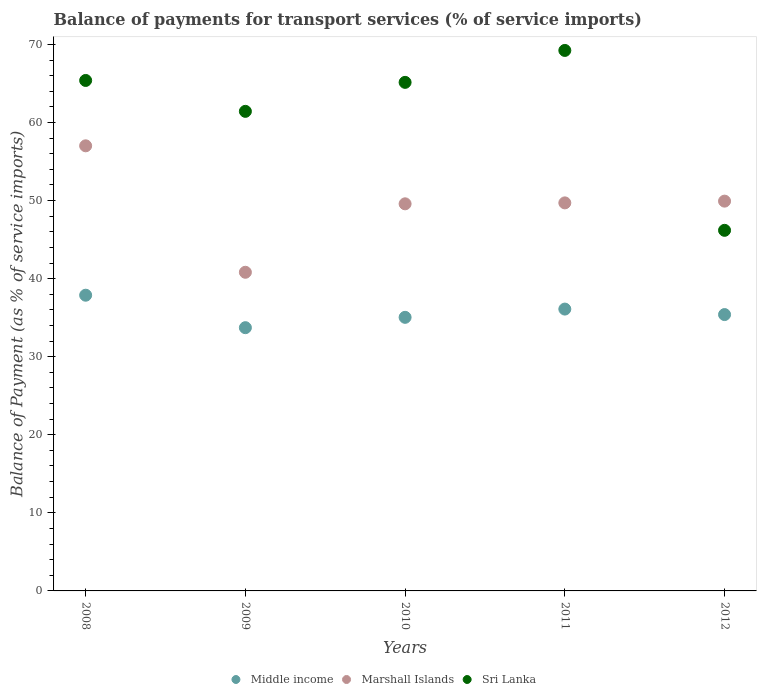How many different coloured dotlines are there?
Make the answer very short. 3. What is the balance of payments for transport services in Marshall Islands in 2009?
Keep it short and to the point. 40.81. Across all years, what is the maximum balance of payments for transport services in Middle income?
Make the answer very short. 37.88. Across all years, what is the minimum balance of payments for transport services in Sri Lanka?
Your answer should be very brief. 46.18. In which year was the balance of payments for transport services in Middle income maximum?
Provide a succinct answer. 2008. In which year was the balance of payments for transport services in Middle income minimum?
Give a very brief answer. 2009. What is the total balance of payments for transport services in Middle income in the graph?
Your response must be concise. 178.12. What is the difference between the balance of payments for transport services in Marshall Islands in 2008 and that in 2009?
Ensure brevity in your answer.  16.2. What is the difference between the balance of payments for transport services in Sri Lanka in 2011 and the balance of payments for transport services in Marshall Islands in 2009?
Ensure brevity in your answer.  28.41. What is the average balance of payments for transport services in Marshall Islands per year?
Keep it short and to the point. 49.41. In the year 2011, what is the difference between the balance of payments for transport services in Marshall Islands and balance of payments for transport services in Middle income?
Provide a succinct answer. 13.6. What is the ratio of the balance of payments for transport services in Marshall Islands in 2008 to that in 2011?
Make the answer very short. 1.15. What is the difference between the highest and the second highest balance of payments for transport services in Sri Lanka?
Give a very brief answer. 3.84. What is the difference between the highest and the lowest balance of payments for transport services in Middle income?
Your answer should be compact. 4.16. In how many years, is the balance of payments for transport services in Sri Lanka greater than the average balance of payments for transport services in Sri Lanka taken over all years?
Offer a terse response. 3. Is it the case that in every year, the sum of the balance of payments for transport services in Sri Lanka and balance of payments for transport services in Marshall Islands  is greater than the balance of payments for transport services in Middle income?
Provide a succinct answer. Yes. Does the balance of payments for transport services in Sri Lanka monotonically increase over the years?
Give a very brief answer. No. Is the balance of payments for transport services in Marshall Islands strictly less than the balance of payments for transport services in Sri Lanka over the years?
Make the answer very short. No. How many dotlines are there?
Give a very brief answer. 3. How many years are there in the graph?
Your answer should be very brief. 5. Does the graph contain any zero values?
Offer a terse response. No. Does the graph contain grids?
Your answer should be compact. No. How many legend labels are there?
Provide a short and direct response. 3. What is the title of the graph?
Provide a short and direct response. Balance of payments for transport services (% of service imports). Does "Belize" appear as one of the legend labels in the graph?
Offer a terse response. No. What is the label or title of the X-axis?
Make the answer very short. Years. What is the label or title of the Y-axis?
Your answer should be very brief. Balance of Payment (as % of service imports). What is the Balance of Payment (as % of service imports) in Middle income in 2008?
Give a very brief answer. 37.88. What is the Balance of Payment (as % of service imports) of Marshall Islands in 2008?
Ensure brevity in your answer.  57.01. What is the Balance of Payment (as % of service imports) in Sri Lanka in 2008?
Make the answer very short. 65.38. What is the Balance of Payment (as % of service imports) in Middle income in 2009?
Offer a terse response. 33.72. What is the Balance of Payment (as % of service imports) of Marshall Islands in 2009?
Your response must be concise. 40.81. What is the Balance of Payment (as % of service imports) of Sri Lanka in 2009?
Keep it short and to the point. 61.42. What is the Balance of Payment (as % of service imports) of Middle income in 2010?
Ensure brevity in your answer.  35.04. What is the Balance of Payment (as % of service imports) of Marshall Islands in 2010?
Keep it short and to the point. 49.58. What is the Balance of Payment (as % of service imports) in Sri Lanka in 2010?
Your answer should be compact. 65.14. What is the Balance of Payment (as % of service imports) of Middle income in 2011?
Provide a short and direct response. 36.1. What is the Balance of Payment (as % of service imports) of Marshall Islands in 2011?
Your answer should be compact. 49.7. What is the Balance of Payment (as % of service imports) of Sri Lanka in 2011?
Ensure brevity in your answer.  69.23. What is the Balance of Payment (as % of service imports) in Middle income in 2012?
Your response must be concise. 35.39. What is the Balance of Payment (as % of service imports) of Marshall Islands in 2012?
Your answer should be very brief. 49.92. What is the Balance of Payment (as % of service imports) of Sri Lanka in 2012?
Your answer should be very brief. 46.18. Across all years, what is the maximum Balance of Payment (as % of service imports) in Middle income?
Keep it short and to the point. 37.88. Across all years, what is the maximum Balance of Payment (as % of service imports) of Marshall Islands?
Ensure brevity in your answer.  57.01. Across all years, what is the maximum Balance of Payment (as % of service imports) in Sri Lanka?
Make the answer very short. 69.23. Across all years, what is the minimum Balance of Payment (as % of service imports) of Middle income?
Make the answer very short. 33.72. Across all years, what is the minimum Balance of Payment (as % of service imports) in Marshall Islands?
Ensure brevity in your answer.  40.81. Across all years, what is the minimum Balance of Payment (as % of service imports) of Sri Lanka?
Provide a short and direct response. 46.18. What is the total Balance of Payment (as % of service imports) of Middle income in the graph?
Provide a succinct answer. 178.12. What is the total Balance of Payment (as % of service imports) in Marshall Islands in the graph?
Give a very brief answer. 247.03. What is the total Balance of Payment (as % of service imports) of Sri Lanka in the graph?
Offer a very short reply. 307.35. What is the difference between the Balance of Payment (as % of service imports) in Middle income in 2008 and that in 2009?
Provide a succinct answer. 4.16. What is the difference between the Balance of Payment (as % of service imports) of Marshall Islands in 2008 and that in 2009?
Provide a succinct answer. 16.2. What is the difference between the Balance of Payment (as % of service imports) in Sri Lanka in 2008 and that in 2009?
Offer a very short reply. 3.96. What is the difference between the Balance of Payment (as % of service imports) of Middle income in 2008 and that in 2010?
Make the answer very short. 2.83. What is the difference between the Balance of Payment (as % of service imports) in Marshall Islands in 2008 and that in 2010?
Provide a succinct answer. 7.43. What is the difference between the Balance of Payment (as % of service imports) in Sri Lanka in 2008 and that in 2010?
Your answer should be compact. 0.24. What is the difference between the Balance of Payment (as % of service imports) in Middle income in 2008 and that in 2011?
Provide a succinct answer. 1.78. What is the difference between the Balance of Payment (as % of service imports) of Marshall Islands in 2008 and that in 2011?
Keep it short and to the point. 7.31. What is the difference between the Balance of Payment (as % of service imports) of Sri Lanka in 2008 and that in 2011?
Your answer should be very brief. -3.84. What is the difference between the Balance of Payment (as % of service imports) in Middle income in 2008 and that in 2012?
Keep it short and to the point. 2.48. What is the difference between the Balance of Payment (as % of service imports) of Marshall Islands in 2008 and that in 2012?
Your answer should be very brief. 7.09. What is the difference between the Balance of Payment (as % of service imports) of Sri Lanka in 2008 and that in 2012?
Your answer should be compact. 19.2. What is the difference between the Balance of Payment (as % of service imports) of Middle income in 2009 and that in 2010?
Provide a short and direct response. -1.32. What is the difference between the Balance of Payment (as % of service imports) of Marshall Islands in 2009 and that in 2010?
Your answer should be very brief. -8.77. What is the difference between the Balance of Payment (as % of service imports) in Sri Lanka in 2009 and that in 2010?
Your answer should be compact. -3.71. What is the difference between the Balance of Payment (as % of service imports) in Middle income in 2009 and that in 2011?
Ensure brevity in your answer.  -2.38. What is the difference between the Balance of Payment (as % of service imports) of Marshall Islands in 2009 and that in 2011?
Your answer should be very brief. -8.89. What is the difference between the Balance of Payment (as % of service imports) of Sri Lanka in 2009 and that in 2011?
Your response must be concise. -7.8. What is the difference between the Balance of Payment (as % of service imports) in Middle income in 2009 and that in 2012?
Make the answer very short. -1.68. What is the difference between the Balance of Payment (as % of service imports) of Marshall Islands in 2009 and that in 2012?
Your response must be concise. -9.11. What is the difference between the Balance of Payment (as % of service imports) in Sri Lanka in 2009 and that in 2012?
Give a very brief answer. 15.24. What is the difference between the Balance of Payment (as % of service imports) in Middle income in 2010 and that in 2011?
Your answer should be very brief. -1.06. What is the difference between the Balance of Payment (as % of service imports) in Marshall Islands in 2010 and that in 2011?
Provide a short and direct response. -0.12. What is the difference between the Balance of Payment (as % of service imports) in Sri Lanka in 2010 and that in 2011?
Provide a succinct answer. -4.09. What is the difference between the Balance of Payment (as % of service imports) in Middle income in 2010 and that in 2012?
Provide a succinct answer. -0.35. What is the difference between the Balance of Payment (as % of service imports) in Marshall Islands in 2010 and that in 2012?
Give a very brief answer. -0.34. What is the difference between the Balance of Payment (as % of service imports) in Sri Lanka in 2010 and that in 2012?
Offer a terse response. 18.95. What is the difference between the Balance of Payment (as % of service imports) in Middle income in 2011 and that in 2012?
Provide a short and direct response. 0.7. What is the difference between the Balance of Payment (as % of service imports) of Marshall Islands in 2011 and that in 2012?
Your answer should be compact. -0.22. What is the difference between the Balance of Payment (as % of service imports) in Sri Lanka in 2011 and that in 2012?
Make the answer very short. 23.04. What is the difference between the Balance of Payment (as % of service imports) in Middle income in 2008 and the Balance of Payment (as % of service imports) in Marshall Islands in 2009?
Provide a short and direct response. -2.94. What is the difference between the Balance of Payment (as % of service imports) of Middle income in 2008 and the Balance of Payment (as % of service imports) of Sri Lanka in 2009?
Offer a terse response. -23.55. What is the difference between the Balance of Payment (as % of service imports) in Marshall Islands in 2008 and the Balance of Payment (as % of service imports) in Sri Lanka in 2009?
Give a very brief answer. -4.41. What is the difference between the Balance of Payment (as % of service imports) in Middle income in 2008 and the Balance of Payment (as % of service imports) in Marshall Islands in 2010?
Your answer should be very brief. -11.7. What is the difference between the Balance of Payment (as % of service imports) of Middle income in 2008 and the Balance of Payment (as % of service imports) of Sri Lanka in 2010?
Make the answer very short. -27.26. What is the difference between the Balance of Payment (as % of service imports) in Marshall Islands in 2008 and the Balance of Payment (as % of service imports) in Sri Lanka in 2010?
Your response must be concise. -8.13. What is the difference between the Balance of Payment (as % of service imports) of Middle income in 2008 and the Balance of Payment (as % of service imports) of Marshall Islands in 2011?
Make the answer very short. -11.82. What is the difference between the Balance of Payment (as % of service imports) in Middle income in 2008 and the Balance of Payment (as % of service imports) in Sri Lanka in 2011?
Provide a short and direct response. -31.35. What is the difference between the Balance of Payment (as % of service imports) of Marshall Islands in 2008 and the Balance of Payment (as % of service imports) of Sri Lanka in 2011?
Provide a succinct answer. -12.22. What is the difference between the Balance of Payment (as % of service imports) of Middle income in 2008 and the Balance of Payment (as % of service imports) of Marshall Islands in 2012?
Make the answer very short. -12.05. What is the difference between the Balance of Payment (as % of service imports) in Middle income in 2008 and the Balance of Payment (as % of service imports) in Sri Lanka in 2012?
Your response must be concise. -8.31. What is the difference between the Balance of Payment (as % of service imports) of Marshall Islands in 2008 and the Balance of Payment (as % of service imports) of Sri Lanka in 2012?
Give a very brief answer. 10.82. What is the difference between the Balance of Payment (as % of service imports) of Middle income in 2009 and the Balance of Payment (as % of service imports) of Marshall Islands in 2010?
Ensure brevity in your answer.  -15.86. What is the difference between the Balance of Payment (as % of service imports) in Middle income in 2009 and the Balance of Payment (as % of service imports) in Sri Lanka in 2010?
Provide a short and direct response. -31.42. What is the difference between the Balance of Payment (as % of service imports) of Marshall Islands in 2009 and the Balance of Payment (as % of service imports) of Sri Lanka in 2010?
Provide a short and direct response. -24.32. What is the difference between the Balance of Payment (as % of service imports) of Middle income in 2009 and the Balance of Payment (as % of service imports) of Marshall Islands in 2011?
Offer a very short reply. -15.98. What is the difference between the Balance of Payment (as % of service imports) in Middle income in 2009 and the Balance of Payment (as % of service imports) in Sri Lanka in 2011?
Provide a short and direct response. -35.51. What is the difference between the Balance of Payment (as % of service imports) in Marshall Islands in 2009 and the Balance of Payment (as % of service imports) in Sri Lanka in 2011?
Your answer should be compact. -28.41. What is the difference between the Balance of Payment (as % of service imports) of Middle income in 2009 and the Balance of Payment (as % of service imports) of Marshall Islands in 2012?
Your response must be concise. -16.21. What is the difference between the Balance of Payment (as % of service imports) in Middle income in 2009 and the Balance of Payment (as % of service imports) in Sri Lanka in 2012?
Your response must be concise. -12.47. What is the difference between the Balance of Payment (as % of service imports) in Marshall Islands in 2009 and the Balance of Payment (as % of service imports) in Sri Lanka in 2012?
Provide a succinct answer. -5.37. What is the difference between the Balance of Payment (as % of service imports) of Middle income in 2010 and the Balance of Payment (as % of service imports) of Marshall Islands in 2011?
Give a very brief answer. -14.66. What is the difference between the Balance of Payment (as % of service imports) of Middle income in 2010 and the Balance of Payment (as % of service imports) of Sri Lanka in 2011?
Your response must be concise. -34.18. What is the difference between the Balance of Payment (as % of service imports) in Marshall Islands in 2010 and the Balance of Payment (as % of service imports) in Sri Lanka in 2011?
Give a very brief answer. -19.65. What is the difference between the Balance of Payment (as % of service imports) of Middle income in 2010 and the Balance of Payment (as % of service imports) of Marshall Islands in 2012?
Give a very brief answer. -14.88. What is the difference between the Balance of Payment (as % of service imports) of Middle income in 2010 and the Balance of Payment (as % of service imports) of Sri Lanka in 2012?
Your response must be concise. -11.14. What is the difference between the Balance of Payment (as % of service imports) in Marshall Islands in 2010 and the Balance of Payment (as % of service imports) in Sri Lanka in 2012?
Keep it short and to the point. 3.4. What is the difference between the Balance of Payment (as % of service imports) of Middle income in 2011 and the Balance of Payment (as % of service imports) of Marshall Islands in 2012?
Offer a very short reply. -13.83. What is the difference between the Balance of Payment (as % of service imports) in Middle income in 2011 and the Balance of Payment (as % of service imports) in Sri Lanka in 2012?
Your answer should be very brief. -10.09. What is the difference between the Balance of Payment (as % of service imports) of Marshall Islands in 2011 and the Balance of Payment (as % of service imports) of Sri Lanka in 2012?
Keep it short and to the point. 3.52. What is the average Balance of Payment (as % of service imports) in Middle income per year?
Your answer should be compact. 35.62. What is the average Balance of Payment (as % of service imports) in Marshall Islands per year?
Your answer should be compact. 49.41. What is the average Balance of Payment (as % of service imports) of Sri Lanka per year?
Make the answer very short. 61.47. In the year 2008, what is the difference between the Balance of Payment (as % of service imports) of Middle income and Balance of Payment (as % of service imports) of Marshall Islands?
Provide a short and direct response. -19.13. In the year 2008, what is the difference between the Balance of Payment (as % of service imports) of Middle income and Balance of Payment (as % of service imports) of Sri Lanka?
Offer a terse response. -27.51. In the year 2008, what is the difference between the Balance of Payment (as % of service imports) in Marshall Islands and Balance of Payment (as % of service imports) in Sri Lanka?
Offer a terse response. -8.37. In the year 2009, what is the difference between the Balance of Payment (as % of service imports) in Middle income and Balance of Payment (as % of service imports) in Marshall Islands?
Your answer should be very brief. -7.1. In the year 2009, what is the difference between the Balance of Payment (as % of service imports) of Middle income and Balance of Payment (as % of service imports) of Sri Lanka?
Make the answer very short. -27.71. In the year 2009, what is the difference between the Balance of Payment (as % of service imports) in Marshall Islands and Balance of Payment (as % of service imports) in Sri Lanka?
Offer a very short reply. -20.61. In the year 2010, what is the difference between the Balance of Payment (as % of service imports) of Middle income and Balance of Payment (as % of service imports) of Marshall Islands?
Make the answer very short. -14.54. In the year 2010, what is the difference between the Balance of Payment (as % of service imports) in Middle income and Balance of Payment (as % of service imports) in Sri Lanka?
Keep it short and to the point. -30.1. In the year 2010, what is the difference between the Balance of Payment (as % of service imports) of Marshall Islands and Balance of Payment (as % of service imports) of Sri Lanka?
Your response must be concise. -15.56. In the year 2011, what is the difference between the Balance of Payment (as % of service imports) of Middle income and Balance of Payment (as % of service imports) of Marshall Islands?
Make the answer very short. -13.6. In the year 2011, what is the difference between the Balance of Payment (as % of service imports) in Middle income and Balance of Payment (as % of service imports) in Sri Lanka?
Your response must be concise. -33.13. In the year 2011, what is the difference between the Balance of Payment (as % of service imports) of Marshall Islands and Balance of Payment (as % of service imports) of Sri Lanka?
Provide a short and direct response. -19.53. In the year 2012, what is the difference between the Balance of Payment (as % of service imports) in Middle income and Balance of Payment (as % of service imports) in Marshall Islands?
Provide a succinct answer. -14.53. In the year 2012, what is the difference between the Balance of Payment (as % of service imports) in Middle income and Balance of Payment (as % of service imports) in Sri Lanka?
Your answer should be very brief. -10.79. In the year 2012, what is the difference between the Balance of Payment (as % of service imports) of Marshall Islands and Balance of Payment (as % of service imports) of Sri Lanka?
Your answer should be very brief. 3.74. What is the ratio of the Balance of Payment (as % of service imports) in Middle income in 2008 to that in 2009?
Your answer should be very brief. 1.12. What is the ratio of the Balance of Payment (as % of service imports) of Marshall Islands in 2008 to that in 2009?
Provide a succinct answer. 1.4. What is the ratio of the Balance of Payment (as % of service imports) in Sri Lanka in 2008 to that in 2009?
Your answer should be very brief. 1.06. What is the ratio of the Balance of Payment (as % of service imports) in Middle income in 2008 to that in 2010?
Offer a very short reply. 1.08. What is the ratio of the Balance of Payment (as % of service imports) of Marshall Islands in 2008 to that in 2010?
Offer a terse response. 1.15. What is the ratio of the Balance of Payment (as % of service imports) in Middle income in 2008 to that in 2011?
Offer a very short reply. 1.05. What is the ratio of the Balance of Payment (as % of service imports) in Marshall Islands in 2008 to that in 2011?
Your answer should be compact. 1.15. What is the ratio of the Balance of Payment (as % of service imports) of Sri Lanka in 2008 to that in 2011?
Your response must be concise. 0.94. What is the ratio of the Balance of Payment (as % of service imports) of Middle income in 2008 to that in 2012?
Your answer should be very brief. 1.07. What is the ratio of the Balance of Payment (as % of service imports) of Marshall Islands in 2008 to that in 2012?
Your answer should be very brief. 1.14. What is the ratio of the Balance of Payment (as % of service imports) of Sri Lanka in 2008 to that in 2012?
Offer a terse response. 1.42. What is the ratio of the Balance of Payment (as % of service imports) in Middle income in 2009 to that in 2010?
Provide a short and direct response. 0.96. What is the ratio of the Balance of Payment (as % of service imports) of Marshall Islands in 2009 to that in 2010?
Give a very brief answer. 0.82. What is the ratio of the Balance of Payment (as % of service imports) of Sri Lanka in 2009 to that in 2010?
Offer a terse response. 0.94. What is the ratio of the Balance of Payment (as % of service imports) in Middle income in 2009 to that in 2011?
Your response must be concise. 0.93. What is the ratio of the Balance of Payment (as % of service imports) of Marshall Islands in 2009 to that in 2011?
Provide a succinct answer. 0.82. What is the ratio of the Balance of Payment (as % of service imports) in Sri Lanka in 2009 to that in 2011?
Your response must be concise. 0.89. What is the ratio of the Balance of Payment (as % of service imports) of Middle income in 2009 to that in 2012?
Ensure brevity in your answer.  0.95. What is the ratio of the Balance of Payment (as % of service imports) of Marshall Islands in 2009 to that in 2012?
Keep it short and to the point. 0.82. What is the ratio of the Balance of Payment (as % of service imports) of Sri Lanka in 2009 to that in 2012?
Make the answer very short. 1.33. What is the ratio of the Balance of Payment (as % of service imports) in Middle income in 2010 to that in 2011?
Give a very brief answer. 0.97. What is the ratio of the Balance of Payment (as % of service imports) in Sri Lanka in 2010 to that in 2011?
Give a very brief answer. 0.94. What is the ratio of the Balance of Payment (as % of service imports) of Sri Lanka in 2010 to that in 2012?
Offer a very short reply. 1.41. What is the ratio of the Balance of Payment (as % of service imports) of Middle income in 2011 to that in 2012?
Ensure brevity in your answer.  1.02. What is the ratio of the Balance of Payment (as % of service imports) in Marshall Islands in 2011 to that in 2012?
Offer a very short reply. 1. What is the ratio of the Balance of Payment (as % of service imports) in Sri Lanka in 2011 to that in 2012?
Give a very brief answer. 1.5. What is the difference between the highest and the second highest Balance of Payment (as % of service imports) in Middle income?
Give a very brief answer. 1.78. What is the difference between the highest and the second highest Balance of Payment (as % of service imports) in Marshall Islands?
Your answer should be compact. 7.09. What is the difference between the highest and the second highest Balance of Payment (as % of service imports) in Sri Lanka?
Provide a short and direct response. 3.84. What is the difference between the highest and the lowest Balance of Payment (as % of service imports) of Middle income?
Your answer should be very brief. 4.16. What is the difference between the highest and the lowest Balance of Payment (as % of service imports) in Marshall Islands?
Your response must be concise. 16.2. What is the difference between the highest and the lowest Balance of Payment (as % of service imports) of Sri Lanka?
Provide a short and direct response. 23.04. 